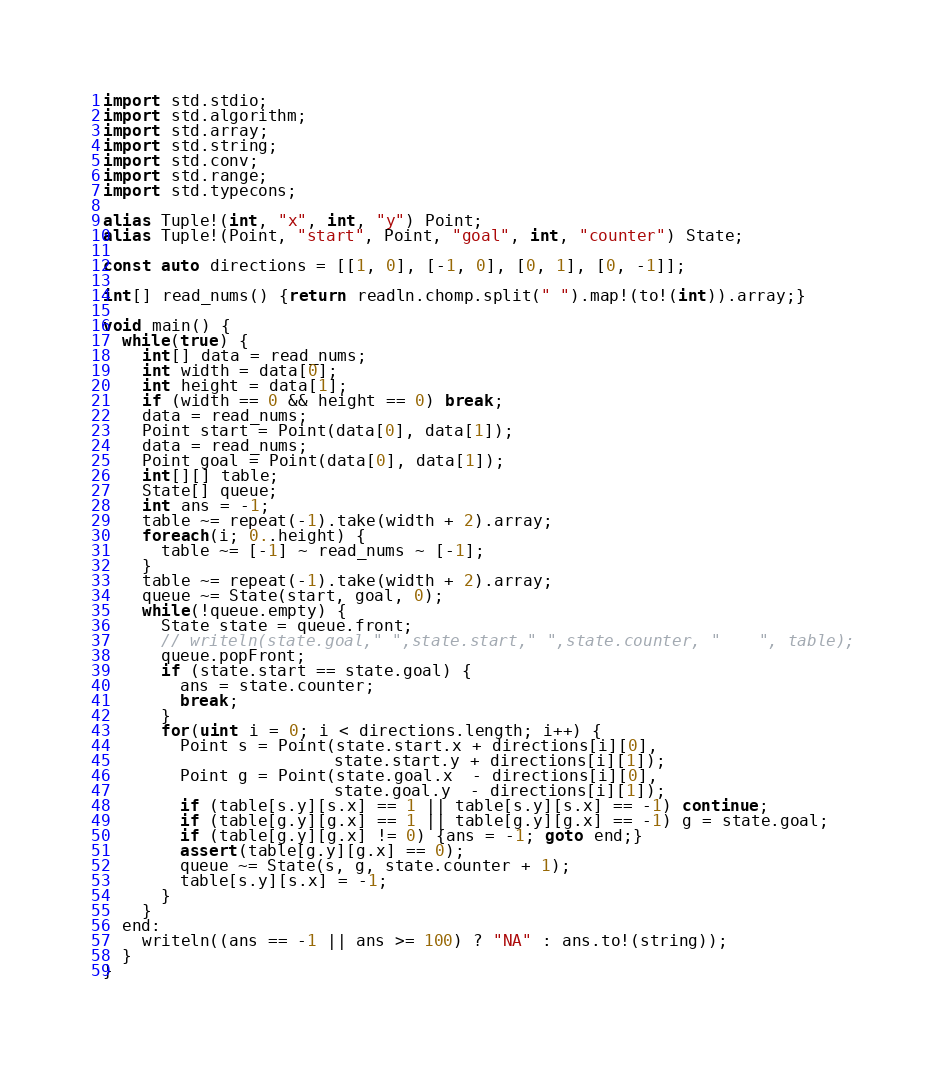<code> <loc_0><loc_0><loc_500><loc_500><_D_>
import std.stdio;
import std.algorithm;
import std.array;
import std.string;
import std.conv;
import std.range;
import std.typecons;

alias Tuple!(int, "x", int, "y") Point;
alias Tuple!(Point, "start", Point, "goal", int, "counter") State;

const auto directions = [[1, 0], [-1, 0], [0, 1], [0, -1]];

int[] read_nums() {return readln.chomp.split(" ").map!(to!(int)).array;}

void main() {
  while(true) {
    int[] data = read_nums;
    int width = data[0];
    int height = data[1];
    if (width == 0 && height == 0) break;
    data = read_nums;
    Point start = Point(data[0], data[1]);
    data = read_nums;
    Point goal = Point(data[0], data[1]);
    int[][] table;
    State[] queue;
    int ans = -1;
    table ~= repeat(-1).take(width + 2).array;
    foreach(i; 0..height) {
      table ~= [-1] ~ read_nums ~ [-1];
    }
    table ~= repeat(-1).take(width + 2).array;
    queue ~= State(start, goal, 0);
    while(!queue.empty) {
      State state = queue.front;
      // writeln(state.goal," ",state.start," ",state.counter, "    ", table);
      queue.popFront;
      if (state.start == state.goal) {
        ans = state.counter;
        break;
      }
      for(uint i = 0; i < directions.length; i++) {
        Point s = Point(state.start.x + directions[i][0],
                        state.start.y + directions[i][1]);
        Point g = Point(state.goal.x  - directions[i][0],
                        state.goal.y  - directions[i][1]);
        if (table[s.y][s.x] == 1 || table[s.y][s.x] == -1) continue;
        if (table[g.y][g.x] == 1 || table[g.y][g.x] == -1) g = state.goal;
        if (table[g.y][g.x] != 0) {ans = -1; goto end;}
        assert(table[g.y][g.x] == 0);
        queue ~= State(s, g, state.counter + 1);
        table[s.y][s.x] = -1;
      }
    }
  end:
    writeln((ans == -1 || ans >= 100) ? "NA" : ans.to!(string));
  }
}</code> 